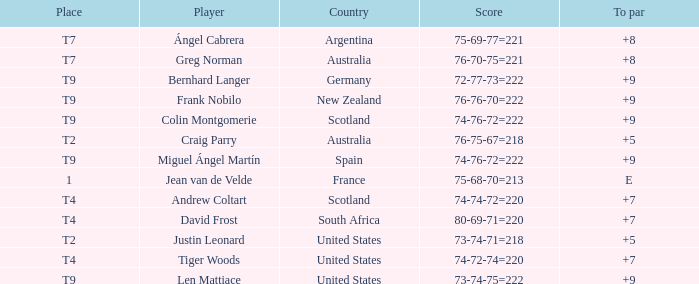What is the place number for the player with a To Par score of 'E'? 1.0. 